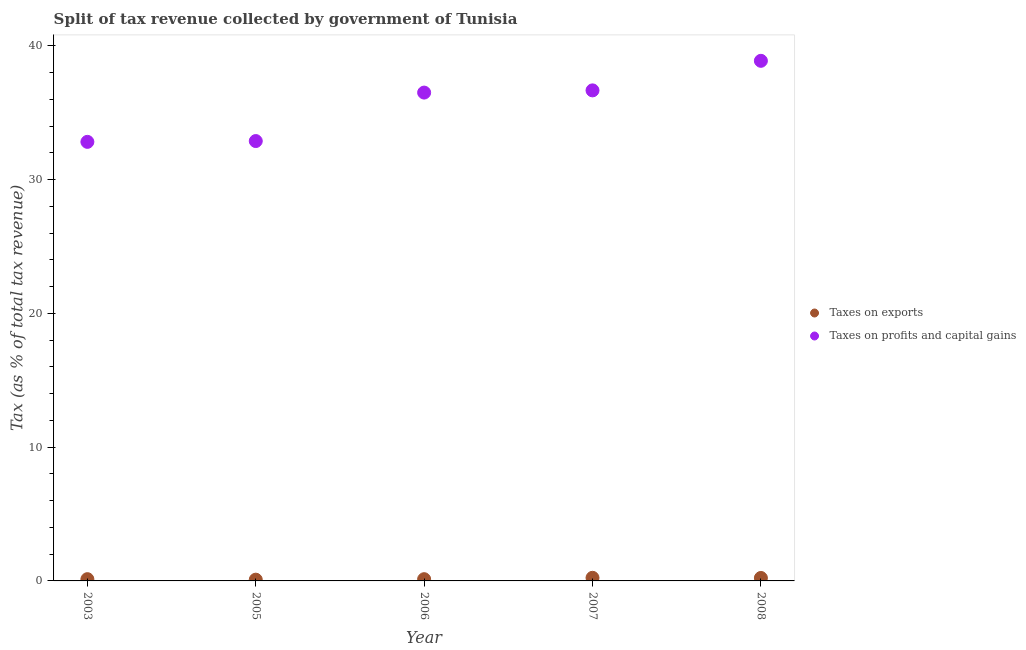What is the percentage of revenue obtained from taxes on profits and capital gains in 2007?
Give a very brief answer. 36.68. Across all years, what is the maximum percentage of revenue obtained from taxes on profits and capital gains?
Make the answer very short. 38.89. Across all years, what is the minimum percentage of revenue obtained from taxes on exports?
Your response must be concise. 0.09. In which year was the percentage of revenue obtained from taxes on exports minimum?
Provide a succinct answer. 2005. What is the total percentage of revenue obtained from taxes on profits and capital gains in the graph?
Offer a terse response. 177.8. What is the difference between the percentage of revenue obtained from taxes on profits and capital gains in 2003 and that in 2007?
Offer a very short reply. -3.85. What is the difference between the percentage of revenue obtained from taxes on exports in 2003 and the percentage of revenue obtained from taxes on profits and capital gains in 2008?
Your answer should be very brief. -38.76. What is the average percentage of revenue obtained from taxes on exports per year?
Keep it short and to the point. 0.16. In the year 2003, what is the difference between the percentage of revenue obtained from taxes on profits and capital gains and percentage of revenue obtained from taxes on exports?
Your answer should be compact. 32.7. What is the ratio of the percentage of revenue obtained from taxes on exports in 2006 to that in 2007?
Your answer should be very brief. 0.56. Is the percentage of revenue obtained from taxes on exports in 2005 less than that in 2006?
Make the answer very short. Yes. What is the difference between the highest and the second highest percentage of revenue obtained from taxes on profits and capital gains?
Provide a succinct answer. 2.21. What is the difference between the highest and the lowest percentage of revenue obtained from taxes on profits and capital gains?
Provide a short and direct response. 6.06. Is the sum of the percentage of revenue obtained from taxes on profits and capital gains in 2007 and 2008 greater than the maximum percentage of revenue obtained from taxes on exports across all years?
Your answer should be very brief. Yes. Does the percentage of revenue obtained from taxes on exports monotonically increase over the years?
Offer a terse response. No. Is the percentage of revenue obtained from taxes on exports strictly greater than the percentage of revenue obtained from taxes on profits and capital gains over the years?
Ensure brevity in your answer.  No. Is the percentage of revenue obtained from taxes on exports strictly less than the percentage of revenue obtained from taxes on profits and capital gains over the years?
Your answer should be compact. Yes. How many dotlines are there?
Your answer should be compact. 2. How many years are there in the graph?
Offer a very short reply. 5. What is the difference between two consecutive major ticks on the Y-axis?
Offer a very short reply. 10. Are the values on the major ticks of Y-axis written in scientific E-notation?
Give a very brief answer. No. Does the graph contain any zero values?
Your answer should be compact. No. Does the graph contain grids?
Offer a terse response. No. Where does the legend appear in the graph?
Give a very brief answer. Center right. How many legend labels are there?
Make the answer very short. 2. What is the title of the graph?
Your answer should be compact. Split of tax revenue collected by government of Tunisia. What is the label or title of the X-axis?
Offer a very short reply. Year. What is the label or title of the Y-axis?
Your response must be concise. Tax (as % of total tax revenue). What is the Tax (as % of total tax revenue) of Taxes on exports in 2003?
Keep it short and to the point. 0.13. What is the Tax (as % of total tax revenue) in Taxes on profits and capital gains in 2003?
Ensure brevity in your answer.  32.83. What is the Tax (as % of total tax revenue) in Taxes on exports in 2005?
Provide a short and direct response. 0.09. What is the Tax (as % of total tax revenue) in Taxes on profits and capital gains in 2005?
Provide a short and direct response. 32.89. What is the Tax (as % of total tax revenue) in Taxes on exports in 2006?
Offer a terse response. 0.13. What is the Tax (as % of total tax revenue) of Taxes on profits and capital gains in 2006?
Keep it short and to the point. 36.51. What is the Tax (as % of total tax revenue) of Taxes on exports in 2007?
Your response must be concise. 0.23. What is the Tax (as % of total tax revenue) of Taxes on profits and capital gains in 2007?
Offer a terse response. 36.68. What is the Tax (as % of total tax revenue) in Taxes on exports in 2008?
Keep it short and to the point. 0.22. What is the Tax (as % of total tax revenue) in Taxes on profits and capital gains in 2008?
Keep it short and to the point. 38.89. Across all years, what is the maximum Tax (as % of total tax revenue) of Taxes on exports?
Your response must be concise. 0.23. Across all years, what is the maximum Tax (as % of total tax revenue) of Taxes on profits and capital gains?
Offer a terse response. 38.89. Across all years, what is the minimum Tax (as % of total tax revenue) in Taxes on exports?
Make the answer very short. 0.09. Across all years, what is the minimum Tax (as % of total tax revenue) in Taxes on profits and capital gains?
Ensure brevity in your answer.  32.83. What is the total Tax (as % of total tax revenue) of Taxes on exports in the graph?
Offer a very short reply. 0.81. What is the total Tax (as % of total tax revenue) of Taxes on profits and capital gains in the graph?
Offer a terse response. 177.8. What is the difference between the Tax (as % of total tax revenue) in Taxes on exports in 2003 and that in 2005?
Your answer should be compact. 0.04. What is the difference between the Tax (as % of total tax revenue) of Taxes on profits and capital gains in 2003 and that in 2005?
Your response must be concise. -0.06. What is the difference between the Tax (as % of total tax revenue) of Taxes on exports in 2003 and that in 2006?
Offer a terse response. 0. What is the difference between the Tax (as % of total tax revenue) in Taxes on profits and capital gains in 2003 and that in 2006?
Ensure brevity in your answer.  -3.68. What is the difference between the Tax (as % of total tax revenue) of Taxes on exports in 2003 and that in 2007?
Provide a succinct answer. -0.1. What is the difference between the Tax (as % of total tax revenue) of Taxes on profits and capital gains in 2003 and that in 2007?
Offer a terse response. -3.85. What is the difference between the Tax (as % of total tax revenue) of Taxes on exports in 2003 and that in 2008?
Ensure brevity in your answer.  -0.09. What is the difference between the Tax (as % of total tax revenue) in Taxes on profits and capital gains in 2003 and that in 2008?
Make the answer very short. -6.06. What is the difference between the Tax (as % of total tax revenue) of Taxes on exports in 2005 and that in 2006?
Offer a terse response. -0.04. What is the difference between the Tax (as % of total tax revenue) in Taxes on profits and capital gains in 2005 and that in 2006?
Your response must be concise. -3.62. What is the difference between the Tax (as % of total tax revenue) of Taxes on exports in 2005 and that in 2007?
Your response must be concise. -0.14. What is the difference between the Tax (as % of total tax revenue) in Taxes on profits and capital gains in 2005 and that in 2007?
Offer a terse response. -3.79. What is the difference between the Tax (as % of total tax revenue) of Taxes on exports in 2005 and that in 2008?
Your answer should be compact. -0.13. What is the difference between the Tax (as % of total tax revenue) in Taxes on profits and capital gains in 2005 and that in 2008?
Your answer should be compact. -6. What is the difference between the Tax (as % of total tax revenue) in Taxes on exports in 2006 and that in 2007?
Your answer should be compact. -0.1. What is the difference between the Tax (as % of total tax revenue) in Taxes on profits and capital gains in 2006 and that in 2007?
Provide a succinct answer. -0.17. What is the difference between the Tax (as % of total tax revenue) of Taxes on exports in 2006 and that in 2008?
Keep it short and to the point. -0.09. What is the difference between the Tax (as % of total tax revenue) in Taxes on profits and capital gains in 2006 and that in 2008?
Offer a very short reply. -2.38. What is the difference between the Tax (as % of total tax revenue) of Taxes on exports in 2007 and that in 2008?
Provide a succinct answer. 0.01. What is the difference between the Tax (as % of total tax revenue) in Taxes on profits and capital gains in 2007 and that in 2008?
Offer a very short reply. -2.21. What is the difference between the Tax (as % of total tax revenue) in Taxes on exports in 2003 and the Tax (as % of total tax revenue) in Taxes on profits and capital gains in 2005?
Your answer should be compact. -32.76. What is the difference between the Tax (as % of total tax revenue) in Taxes on exports in 2003 and the Tax (as % of total tax revenue) in Taxes on profits and capital gains in 2006?
Make the answer very short. -36.38. What is the difference between the Tax (as % of total tax revenue) of Taxes on exports in 2003 and the Tax (as % of total tax revenue) of Taxes on profits and capital gains in 2007?
Offer a terse response. -36.55. What is the difference between the Tax (as % of total tax revenue) of Taxes on exports in 2003 and the Tax (as % of total tax revenue) of Taxes on profits and capital gains in 2008?
Keep it short and to the point. -38.76. What is the difference between the Tax (as % of total tax revenue) of Taxes on exports in 2005 and the Tax (as % of total tax revenue) of Taxes on profits and capital gains in 2006?
Give a very brief answer. -36.42. What is the difference between the Tax (as % of total tax revenue) of Taxes on exports in 2005 and the Tax (as % of total tax revenue) of Taxes on profits and capital gains in 2007?
Your answer should be very brief. -36.59. What is the difference between the Tax (as % of total tax revenue) of Taxes on exports in 2005 and the Tax (as % of total tax revenue) of Taxes on profits and capital gains in 2008?
Offer a very short reply. -38.8. What is the difference between the Tax (as % of total tax revenue) in Taxes on exports in 2006 and the Tax (as % of total tax revenue) in Taxes on profits and capital gains in 2007?
Provide a short and direct response. -36.55. What is the difference between the Tax (as % of total tax revenue) of Taxes on exports in 2006 and the Tax (as % of total tax revenue) of Taxes on profits and capital gains in 2008?
Offer a terse response. -38.76. What is the difference between the Tax (as % of total tax revenue) in Taxes on exports in 2007 and the Tax (as % of total tax revenue) in Taxes on profits and capital gains in 2008?
Your response must be concise. -38.66. What is the average Tax (as % of total tax revenue) of Taxes on exports per year?
Offer a very short reply. 0.16. What is the average Tax (as % of total tax revenue) in Taxes on profits and capital gains per year?
Ensure brevity in your answer.  35.56. In the year 2003, what is the difference between the Tax (as % of total tax revenue) of Taxes on exports and Tax (as % of total tax revenue) of Taxes on profits and capital gains?
Offer a very short reply. -32.7. In the year 2005, what is the difference between the Tax (as % of total tax revenue) in Taxes on exports and Tax (as % of total tax revenue) in Taxes on profits and capital gains?
Provide a succinct answer. -32.8. In the year 2006, what is the difference between the Tax (as % of total tax revenue) of Taxes on exports and Tax (as % of total tax revenue) of Taxes on profits and capital gains?
Ensure brevity in your answer.  -36.38. In the year 2007, what is the difference between the Tax (as % of total tax revenue) of Taxes on exports and Tax (as % of total tax revenue) of Taxes on profits and capital gains?
Ensure brevity in your answer.  -36.45. In the year 2008, what is the difference between the Tax (as % of total tax revenue) of Taxes on exports and Tax (as % of total tax revenue) of Taxes on profits and capital gains?
Provide a short and direct response. -38.67. What is the ratio of the Tax (as % of total tax revenue) of Taxes on exports in 2003 to that in 2005?
Make the answer very short. 1.4. What is the ratio of the Tax (as % of total tax revenue) of Taxes on profits and capital gains in 2003 to that in 2005?
Offer a very short reply. 1. What is the ratio of the Tax (as % of total tax revenue) in Taxes on exports in 2003 to that in 2006?
Give a very brief answer. 1.01. What is the ratio of the Tax (as % of total tax revenue) of Taxes on profits and capital gains in 2003 to that in 2006?
Give a very brief answer. 0.9. What is the ratio of the Tax (as % of total tax revenue) of Taxes on exports in 2003 to that in 2007?
Provide a short and direct response. 0.56. What is the ratio of the Tax (as % of total tax revenue) in Taxes on profits and capital gains in 2003 to that in 2007?
Your answer should be compact. 0.9. What is the ratio of the Tax (as % of total tax revenue) in Taxes on exports in 2003 to that in 2008?
Your response must be concise. 0.59. What is the ratio of the Tax (as % of total tax revenue) of Taxes on profits and capital gains in 2003 to that in 2008?
Your answer should be very brief. 0.84. What is the ratio of the Tax (as % of total tax revenue) of Taxes on exports in 2005 to that in 2006?
Make the answer very short. 0.72. What is the ratio of the Tax (as % of total tax revenue) of Taxes on profits and capital gains in 2005 to that in 2006?
Provide a succinct answer. 0.9. What is the ratio of the Tax (as % of total tax revenue) in Taxes on exports in 2005 to that in 2007?
Offer a terse response. 0.4. What is the ratio of the Tax (as % of total tax revenue) in Taxes on profits and capital gains in 2005 to that in 2007?
Your answer should be compact. 0.9. What is the ratio of the Tax (as % of total tax revenue) in Taxes on exports in 2005 to that in 2008?
Offer a terse response. 0.42. What is the ratio of the Tax (as % of total tax revenue) in Taxes on profits and capital gains in 2005 to that in 2008?
Your answer should be very brief. 0.85. What is the ratio of the Tax (as % of total tax revenue) of Taxes on exports in 2006 to that in 2007?
Offer a terse response. 0.56. What is the ratio of the Tax (as % of total tax revenue) of Taxes on exports in 2006 to that in 2008?
Ensure brevity in your answer.  0.59. What is the ratio of the Tax (as % of total tax revenue) in Taxes on profits and capital gains in 2006 to that in 2008?
Your response must be concise. 0.94. What is the ratio of the Tax (as % of total tax revenue) in Taxes on exports in 2007 to that in 2008?
Keep it short and to the point. 1.05. What is the ratio of the Tax (as % of total tax revenue) in Taxes on profits and capital gains in 2007 to that in 2008?
Your response must be concise. 0.94. What is the difference between the highest and the second highest Tax (as % of total tax revenue) of Taxes on exports?
Make the answer very short. 0.01. What is the difference between the highest and the second highest Tax (as % of total tax revenue) in Taxes on profits and capital gains?
Your answer should be very brief. 2.21. What is the difference between the highest and the lowest Tax (as % of total tax revenue) of Taxes on exports?
Your response must be concise. 0.14. What is the difference between the highest and the lowest Tax (as % of total tax revenue) of Taxes on profits and capital gains?
Your response must be concise. 6.06. 